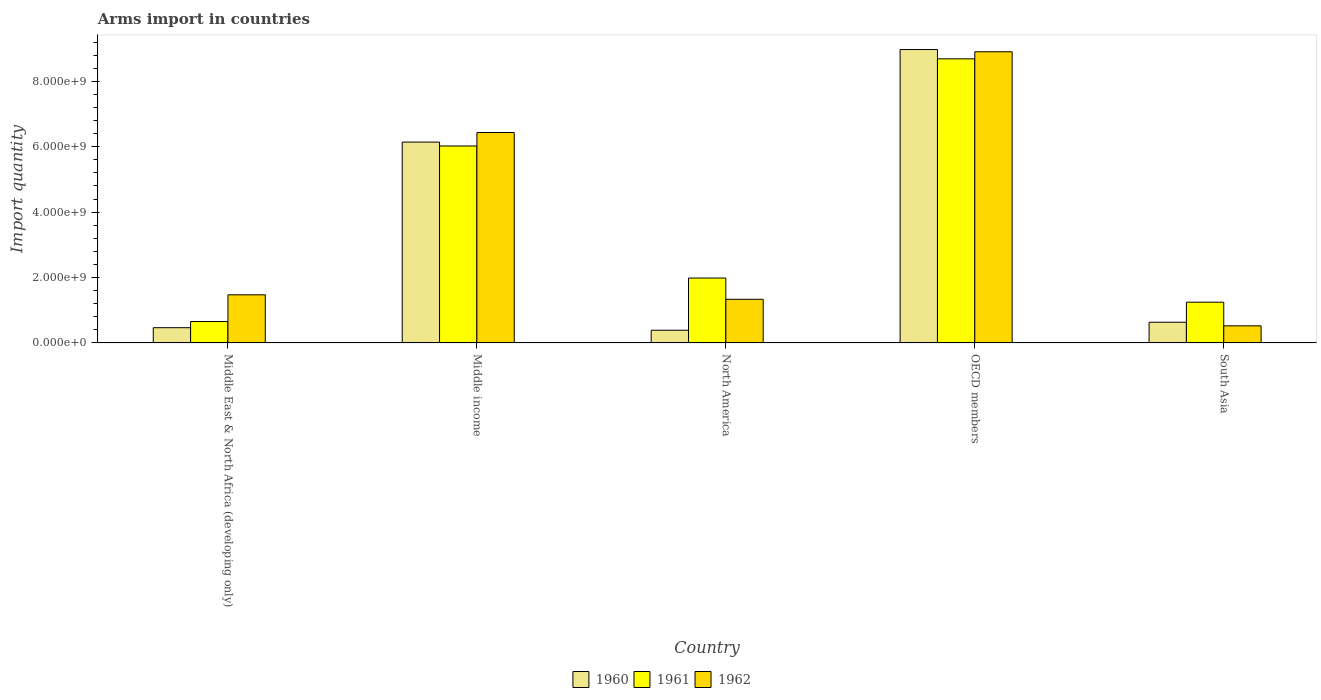Are the number of bars per tick equal to the number of legend labels?
Offer a terse response. Yes. What is the label of the 1st group of bars from the left?
Offer a very short reply. Middle East & North Africa (developing only). In how many cases, is the number of bars for a given country not equal to the number of legend labels?
Your answer should be compact. 0. What is the total arms import in 1962 in OECD members?
Your answer should be compact. 8.90e+09. Across all countries, what is the maximum total arms import in 1962?
Offer a terse response. 8.90e+09. Across all countries, what is the minimum total arms import in 1960?
Ensure brevity in your answer.  3.89e+08. What is the total total arms import in 1960 in the graph?
Ensure brevity in your answer.  1.66e+1. What is the difference between the total arms import in 1961 in Middle East & North Africa (developing only) and that in Middle income?
Ensure brevity in your answer.  -5.37e+09. What is the difference between the total arms import in 1960 in Middle income and the total arms import in 1961 in OECD members?
Give a very brief answer. -2.55e+09. What is the average total arms import in 1960 per country?
Your response must be concise. 3.32e+09. What is the difference between the total arms import of/in 1962 and total arms import of/in 1961 in OECD members?
Offer a terse response. 2.16e+08. What is the ratio of the total arms import in 1962 in North America to that in South Asia?
Give a very brief answer. 2.55. What is the difference between the highest and the second highest total arms import in 1961?
Give a very brief answer. 2.66e+09. What is the difference between the highest and the lowest total arms import in 1960?
Your answer should be very brief. 8.58e+09. Are all the bars in the graph horizontal?
Your answer should be compact. No. How many countries are there in the graph?
Provide a short and direct response. 5. What is the title of the graph?
Your response must be concise. Arms import in countries. What is the label or title of the Y-axis?
Offer a terse response. Import quantity. What is the Import quantity of 1960 in Middle East & North Africa (developing only)?
Ensure brevity in your answer.  4.66e+08. What is the Import quantity in 1961 in Middle East & North Africa (developing only)?
Give a very brief answer. 6.55e+08. What is the Import quantity of 1962 in Middle East & North Africa (developing only)?
Provide a succinct answer. 1.47e+09. What is the Import quantity of 1960 in Middle income?
Ensure brevity in your answer.  6.14e+09. What is the Import quantity in 1961 in Middle income?
Your answer should be very brief. 6.02e+09. What is the Import quantity of 1962 in Middle income?
Offer a very short reply. 6.44e+09. What is the Import quantity in 1960 in North America?
Offer a terse response. 3.89e+08. What is the Import quantity of 1961 in North America?
Provide a succinct answer. 1.98e+09. What is the Import quantity of 1962 in North America?
Provide a succinct answer. 1.34e+09. What is the Import quantity of 1960 in OECD members?
Offer a very short reply. 8.97e+09. What is the Import quantity in 1961 in OECD members?
Your response must be concise. 8.69e+09. What is the Import quantity in 1962 in OECD members?
Keep it short and to the point. 8.90e+09. What is the Import quantity of 1960 in South Asia?
Give a very brief answer. 6.33e+08. What is the Import quantity in 1961 in South Asia?
Provide a succinct answer. 1.25e+09. What is the Import quantity in 1962 in South Asia?
Keep it short and to the point. 5.23e+08. Across all countries, what is the maximum Import quantity of 1960?
Provide a succinct answer. 8.97e+09. Across all countries, what is the maximum Import quantity of 1961?
Make the answer very short. 8.69e+09. Across all countries, what is the maximum Import quantity of 1962?
Provide a succinct answer. 8.90e+09. Across all countries, what is the minimum Import quantity in 1960?
Provide a succinct answer. 3.89e+08. Across all countries, what is the minimum Import quantity of 1961?
Provide a short and direct response. 6.55e+08. Across all countries, what is the minimum Import quantity in 1962?
Offer a terse response. 5.23e+08. What is the total Import quantity of 1960 in the graph?
Your response must be concise. 1.66e+1. What is the total Import quantity in 1961 in the graph?
Provide a succinct answer. 1.86e+1. What is the total Import quantity in 1962 in the graph?
Your response must be concise. 1.87e+1. What is the difference between the Import quantity of 1960 in Middle East & North Africa (developing only) and that in Middle income?
Ensure brevity in your answer.  -5.68e+09. What is the difference between the Import quantity of 1961 in Middle East & North Africa (developing only) and that in Middle income?
Your answer should be very brief. -5.37e+09. What is the difference between the Import quantity of 1962 in Middle East & North Africa (developing only) and that in Middle income?
Offer a very short reply. -4.96e+09. What is the difference between the Import quantity in 1960 in Middle East & North Africa (developing only) and that in North America?
Your answer should be very brief. 7.70e+07. What is the difference between the Import quantity in 1961 in Middle East & North Africa (developing only) and that in North America?
Offer a very short reply. -1.33e+09. What is the difference between the Import quantity of 1962 in Middle East & North Africa (developing only) and that in North America?
Your answer should be very brief. 1.37e+08. What is the difference between the Import quantity in 1960 in Middle East & North Africa (developing only) and that in OECD members?
Offer a terse response. -8.51e+09. What is the difference between the Import quantity in 1961 in Middle East & North Africa (developing only) and that in OECD members?
Your answer should be compact. -8.03e+09. What is the difference between the Import quantity of 1962 in Middle East & North Africa (developing only) and that in OECD members?
Your response must be concise. -7.43e+09. What is the difference between the Import quantity in 1960 in Middle East & North Africa (developing only) and that in South Asia?
Offer a very short reply. -1.67e+08. What is the difference between the Import quantity of 1961 in Middle East & North Africa (developing only) and that in South Asia?
Make the answer very short. -5.91e+08. What is the difference between the Import quantity in 1962 in Middle East & North Africa (developing only) and that in South Asia?
Make the answer very short. 9.49e+08. What is the difference between the Import quantity of 1960 in Middle income and that in North America?
Your response must be concise. 5.75e+09. What is the difference between the Import quantity of 1961 in Middle income and that in North America?
Keep it short and to the point. 4.04e+09. What is the difference between the Import quantity in 1962 in Middle income and that in North America?
Offer a very short reply. 5.10e+09. What is the difference between the Import quantity in 1960 in Middle income and that in OECD members?
Offer a very short reply. -2.83e+09. What is the difference between the Import quantity in 1961 in Middle income and that in OECD members?
Ensure brevity in your answer.  -2.66e+09. What is the difference between the Import quantity in 1962 in Middle income and that in OECD members?
Your answer should be compact. -2.47e+09. What is the difference between the Import quantity of 1960 in Middle income and that in South Asia?
Offer a terse response. 5.51e+09. What is the difference between the Import quantity of 1961 in Middle income and that in South Asia?
Your response must be concise. 4.78e+09. What is the difference between the Import quantity in 1962 in Middle income and that in South Asia?
Your response must be concise. 5.91e+09. What is the difference between the Import quantity in 1960 in North America and that in OECD members?
Make the answer very short. -8.58e+09. What is the difference between the Import quantity in 1961 in North America and that in OECD members?
Ensure brevity in your answer.  -6.70e+09. What is the difference between the Import quantity in 1962 in North America and that in OECD members?
Provide a succinct answer. -7.57e+09. What is the difference between the Import quantity in 1960 in North America and that in South Asia?
Give a very brief answer. -2.44e+08. What is the difference between the Import quantity of 1961 in North America and that in South Asia?
Your response must be concise. 7.39e+08. What is the difference between the Import quantity in 1962 in North America and that in South Asia?
Your answer should be very brief. 8.12e+08. What is the difference between the Import quantity in 1960 in OECD members and that in South Asia?
Keep it short and to the point. 8.34e+09. What is the difference between the Import quantity of 1961 in OECD members and that in South Asia?
Keep it short and to the point. 7.44e+09. What is the difference between the Import quantity in 1962 in OECD members and that in South Asia?
Offer a very short reply. 8.38e+09. What is the difference between the Import quantity in 1960 in Middle East & North Africa (developing only) and the Import quantity in 1961 in Middle income?
Your response must be concise. -5.56e+09. What is the difference between the Import quantity in 1960 in Middle East & North Africa (developing only) and the Import quantity in 1962 in Middle income?
Your answer should be very brief. -5.97e+09. What is the difference between the Import quantity in 1961 in Middle East & North Africa (developing only) and the Import quantity in 1962 in Middle income?
Provide a short and direct response. -5.78e+09. What is the difference between the Import quantity of 1960 in Middle East & North Africa (developing only) and the Import quantity of 1961 in North America?
Offer a very short reply. -1.52e+09. What is the difference between the Import quantity of 1960 in Middle East & North Africa (developing only) and the Import quantity of 1962 in North America?
Give a very brief answer. -8.69e+08. What is the difference between the Import quantity in 1961 in Middle East & North Africa (developing only) and the Import quantity in 1962 in North America?
Provide a succinct answer. -6.80e+08. What is the difference between the Import quantity in 1960 in Middle East & North Africa (developing only) and the Import quantity in 1961 in OECD members?
Provide a short and direct response. -8.22e+09. What is the difference between the Import quantity of 1960 in Middle East & North Africa (developing only) and the Import quantity of 1962 in OECD members?
Offer a terse response. -8.44e+09. What is the difference between the Import quantity in 1961 in Middle East & North Africa (developing only) and the Import quantity in 1962 in OECD members?
Your answer should be very brief. -8.25e+09. What is the difference between the Import quantity in 1960 in Middle East & North Africa (developing only) and the Import quantity in 1961 in South Asia?
Provide a short and direct response. -7.80e+08. What is the difference between the Import quantity of 1960 in Middle East & North Africa (developing only) and the Import quantity of 1962 in South Asia?
Offer a very short reply. -5.70e+07. What is the difference between the Import quantity of 1961 in Middle East & North Africa (developing only) and the Import quantity of 1962 in South Asia?
Make the answer very short. 1.32e+08. What is the difference between the Import quantity in 1960 in Middle income and the Import quantity in 1961 in North America?
Ensure brevity in your answer.  4.16e+09. What is the difference between the Import quantity in 1960 in Middle income and the Import quantity in 1962 in North America?
Your answer should be very brief. 4.81e+09. What is the difference between the Import quantity of 1961 in Middle income and the Import quantity of 1962 in North America?
Keep it short and to the point. 4.69e+09. What is the difference between the Import quantity of 1960 in Middle income and the Import quantity of 1961 in OECD members?
Provide a short and direct response. -2.55e+09. What is the difference between the Import quantity of 1960 in Middle income and the Import quantity of 1962 in OECD members?
Your answer should be compact. -2.76e+09. What is the difference between the Import quantity of 1961 in Middle income and the Import quantity of 1962 in OECD members?
Offer a very short reply. -2.88e+09. What is the difference between the Import quantity in 1960 in Middle income and the Import quantity in 1961 in South Asia?
Offer a very short reply. 4.90e+09. What is the difference between the Import quantity of 1960 in Middle income and the Import quantity of 1962 in South Asia?
Your response must be concise. 5.62e+09. What is the difference between the Import quantity of 1961 in Middle income and the Import quantity of 1962 in South Asia?
Provide a succinct answer. 5.50e+09. What is the difference between the Import quantity of 1960 in North America and the Import quantity of 1961 in OECD members?
Give a very brief answer. -8.30e+09. What is the difference between the Import quantity of 1960 in North America and the Import quantity of 1962 in OECD members?
Your response must be concise. -8.52e+09. What is the difference between the Import quantity in 1961 in North America and the Import quantity in 1962 in OECD members?
Provide a succinct answer. -6.92e+09. What is the difference between the Import quantity in 1960 in North America and the Import quantity in 1961 in South Asia?
Your response must be concise. -8.57e+08. What is the difference between the Import quantity of 1960 in North America and the Import quantity of 1962 in South Asia?
Offer a terse response. -1.34e+08. What is the difference between the Import quantity in 1961 in North America and the Import quantity in 1962 in South Asia?
Your answer should be compact. 1.46e+09. What is the difference between the Import quantity in 1960 in OECD members and the Import quantity in 1961 in South Asia?
Your response must be concise. 7.73e+09. What is the difference between the Import quantity of 1960 in OECD members and the Import quantity of 1962 in South Asia?
Give a very brief answer. 8.45e+09. What is the difference between the Import quantity of 1961 in OECD members and the Import quantity of 1962 in South Asia?
Give a very brief answer. 8.17e+09. What is the average Import quantity in 1960 per country?
Offer a very short reply. 3.32e+09. What is the average Import quantity of 1961 per country?
Give a very brief answer. 3.72e+09. What is the average Import quantity of 1962 per country?
Provide a succinct answer. 3.73e+09. What is the difference between the Import quantity in 1960 and Import quantity in 1961 in Middle East & North Africa (developing only)?
Ensure brevity in your answer.  -1.89e+08. What is the difference between the Import quantity in 1960 and Import quantity in 1962 in Middle East & North Africa (developing only)?
Provide a short and direct response. -1.01e+09. What is the difference between the Import quantity of 1961 and Import quantity of 1962 in Middle East & North Africa (developing only)?
Give a very brief answer. -8.17e+08. What is the difference between the Import quantity in 1960 and Import quantity in 1961 in Middle income?
Ensure brevity in your answer.  1.19e+08. What is the difference between the Import quantity of 1960 and Import quantity of 1962 in Middle income?
Provide a short and direct response. -2.92e+08. What is the difference between the Import quantity of 1961 and Import quantity of 1962 in Middle income?
Provide a short and direct response. -4.11e+08. What is the difference between the Import quantity in 1960 and Import quantity in 1961 in North America?
Give a very brief answer. -1.60e+09. What is the difference between the Import quantity in 1960 and Import quantity in 1962 in North America?
Your answer should be very brief. -9.46e+08. What is the difference between the Import quantity of 1961 and Import quantity of 1962 in North America?
Make the answer very short. 6.50e+08. What is the difference between the Import quantity in 1960 and Import quantity in 1961 in OECD members?
Offer a very short reply. 2.84e+08. What is the difference between the Import quantity of 1960 and Import quantity of 1962 in OECD members?
Keep it short and to the point. 6.80e+07. What is the difference between the Import quantity of 1961 and Import quantity of 1962 in OECD members?
Offer a very short reply. -2.16e+08. What is the difference between the Import quantity of 1960 and Import quantity of 1961 in South Asia?
Your answer should be compact. -6.13e+08. What is the difference between the Import quantity of 1960 and Import quantity of 1962 in South Asia?
Ensure brevity in your answer.  1.10e+08. What is the difference between the Import quantity in 1961 and Import quantity in 1962 in South Asia?
Ensure brevity in your answer.  7.23e+08. What is the ratio of the Import quantity of 1960 in Middle East & North Africa (developing only) to that in Middle income?
Your response must be concise. 0.08. What is the ratio of the Import quantity in 1961 in Middle East & North Africa (developing only) to that in Middle income?
Your answer should be compact. 0.11. What is the ratio of the Import quantity in 1962 in Middle East & North Africa (developing only) to that in Middle income?
Offer a very short reply. 0.23. What is the ratio of the Import quantity of 1960 in Middle East & North Africa (developing only) to that in North America?
Keep it short and to the point. 1.2. What is the ratio of the Import quantity in 1961 in Middle East & North Africa (developing only) to that in North America?
Keep it short and to the point. 0.33. What is the ratio of the Import quantity of 1962 in Middle East & North Africa (developing only) to that in North America?
Keep it short and to the point. 1.1. What is the ratio of the Import quantity of 1960 in Middle East & North Africa (developing only) to that in OECD members?
Your answer should be compact. 0.05. What is the ratio of the Import quantity in 1961 in Middle East & North Africa (developing only) to that in OECD members?
Keep it short and to the point. 0.08. What is the ratio of the Import quantity of 1962 in Middle East & North Africa (developing only) to that in OECD members?
Your response must be concise. 0.17. What is the ratio of the Import quantity of 1960 in Middle East & North Africa (developing only) to that in South Asia?
Your answer should be very brief. 0.74. What is the ratio of the Import quantity in 1961 in Middle East & North Africa (developing only) to that in South Asia?
Offer a very short reply. 0.53. What is the ratio of the Import quantity in 1962 in Middle East & North Africa (developing only) to that in South Asia?
Your answer should be compact. 2.81. What is the ratio of the Import quantity of 1960 in Middle income to that in North America?
Your response must be concise. 15.79. What is the ratio of the Import quantity of 1961 in Middle income to that in North America?
Provide a succinct answer. 3.03. What is the ratio of the Import quantity of 1962 in Middle income to that in North America?
Offer a very short reply. 4.82. What is the ratio of the Import quantity of 1960 in Middle income to that in OECD members?
Your answer should be compact. 0.68. What is the ratio of the Import quantity of 1961 in Middle income to that in OECD members?
Give a very brief answer. 0.69. What is the ratio of the Import quantity in 1962 in Middle income to that in OECD members?
Provide a succinct answer. 0.72. What is the ratio of the Import quantity of 1960 in Middle income to that in South Asia?
Your response must be concise. 9.7. What is the ratio of the Import quantity in 1961 in Middle income to that in South Asia?
Provide a short and direct response. 4.83. What is the ratio of the Import quantity of 1962 in Middle income to that in South Asia?
Provide a succinct answer. 12.3. What is the ratio of the Import quantity of 1960 in North America to that in OECD members?
Provide a short and direct response. 0.04. What is the ratio of the Import quantity of 1961 in North America to that in OECD members?
Provide a short and direct response. 0.23. What is the ratio of the Import quantity of 1962 in North America to that in OECD members?
Offer a very short reply. 0.15. What is the ratio of the Import quantity in 1960 in North America to that in South Asia?
Provide a short and direct response. 0.61. What is the ratio of the Import quantity of 1961 in North America to that in South Asia?
Your answer should be compact. 1.59. What is the ratio of the Import quantity in 1962 in North America to that in South Asia?
Your answer should be compact. 2.55. What is the ratio of the Import quantity in 1960 in OECD members to that in South Asia?
Provide a succinct answer. 14.18. What is the ratio of the Import quantity in 1961 in OECD members to that in South Asia?
Ensure brevity in your answer.  6.97. What is the ratio of the Import quantity of 1962 in OECD members to that in South Asia?
Offer a terse response. 17.03. What is the difference between the highest and the second highest Import quantity in 1960?
Provide a short and direct response. 2.83e+09. What is the difference between the highest and the second highest Import quantity in 1961?
Offer a very short reply. 2.66e+09. What is the difference between the highest and the second highest Import quantity of 1962?
Provide a succinct answer. 2.47e+09. What is the difference between the highest and the lowest Import quantity of 1960?
Your response must be concise. 8.58e+09. What is the difference between the highest and the lowest Import quantity in 1961?
Offer a very short reply. 8.03e+09. What is the difference between the highest and the lowest Import quantity in 1962?
Your answer should be very brief. 8.38e+09. 